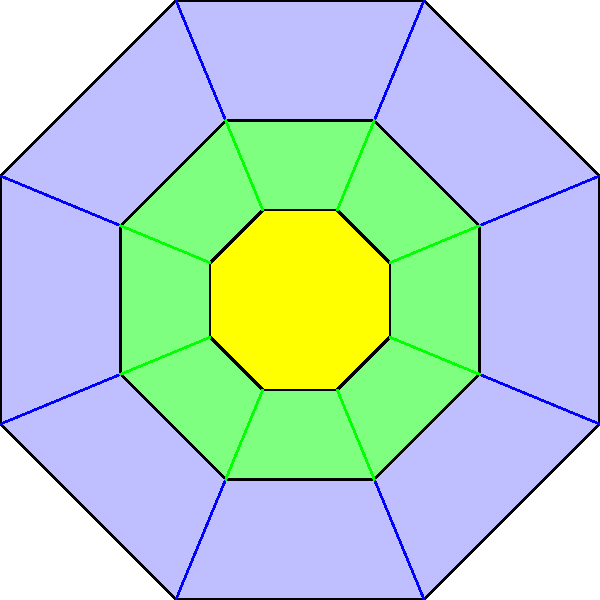The geometric pattern shown above is commonly found in the architectural designs of mosques and administrative buildings in Pakistan. How many lines of symmetry does this pattern have, and how might this symmetry relate to the principles of local administration in different regions of Pakistan? To answer this question, we need to analyze the geometric pattern and its symmetrical properties:

1. The pattern consists of three concentric regular octagons.
2. A regular octagon has 8 lines of symmetry:
   a. 4 lines passing through opposite vertices
   b. 4 lines passing through the midpoints of opposite sides

3. These 8 lines of symmetry are preserved in the concentric arrangement.

4. The symmetry in this pattern relates to local administration principles in Pakistan in several ways:

   a. Balance and equality: The 8-fold symmetry represents the idea of balanced governance and equal treatment of different regions or constituencies.
   
   b. Central authority with regional divisions: The concentric octagons can symbolize a central government (inner octagon) with surrounding administrative regions (outer octagons).
   
   c. Interconnectedness: The lines connecting the vertices of the octagons represent the communication and coordination between different levels of administration.
   
   d. Cultural significance: The use of geometric patterns in administrative buildings reflects the integration of Islamic artistic traditions in governance structures.
   
   e. Historical continuity: The use of such patterns in both historical and modern buildings demonstrates the continuity of cultural and administrative practices across different periods in Pakistan's history.

5. The number of lines of symmetry (8) could also represent the division of administrative responsibilities or the number of key administrative regions in certain historical or contemporary governance structures in Pakistan.
Answer: 8 lines of symmetry; represents balanced governance, regional divisions, and cultural continuity in administration 